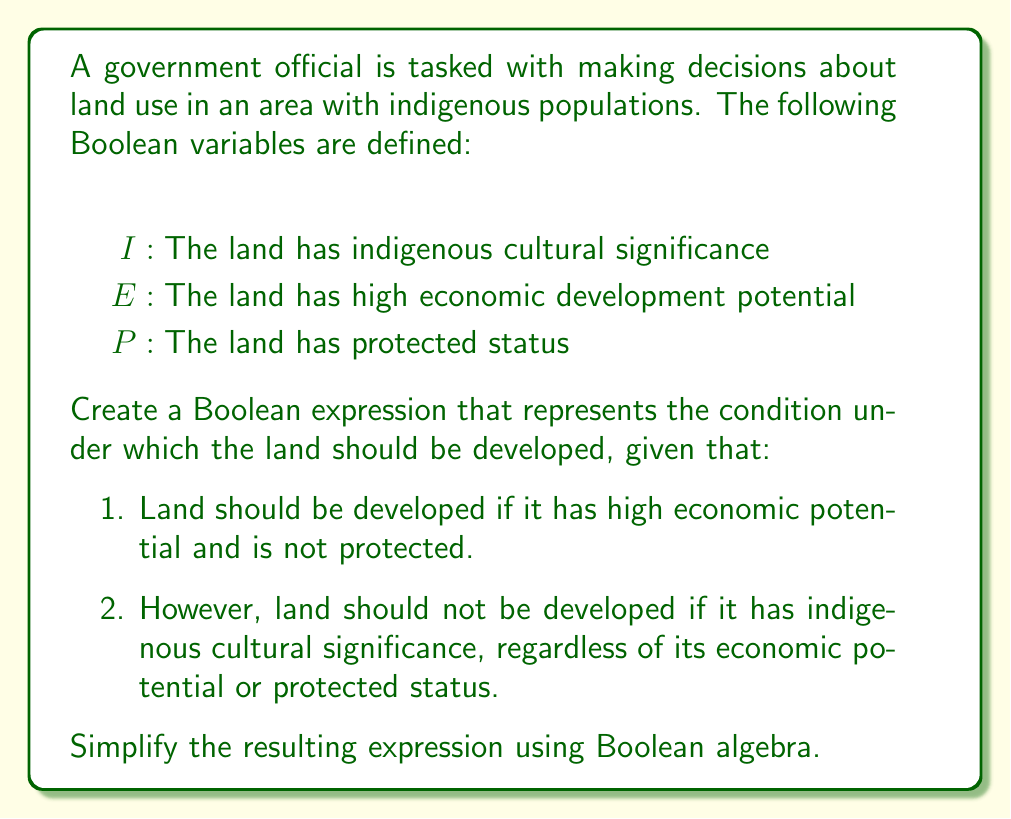What is the answer to this math problem? Let's approach this step-by-step:

1) First, let's express the conditions for development in Boolean terms:
   - Condition for development: $E \wedge \neg P$
   - Condition against development due to indigenous significance: $I$

2) The overall condition for development can be expressed as:
   $D = (E \wedge \neg P) \wedge \neg I$

3) Now, let's simplify this expression using Boolean algebra laws:
   $D = (E \wedge \neg P) \wedge \neg I$
   $= E \wedge \neg P \wedge \neg I$  (Associative law)

4) This expression is already in its simplest form, as it's a conjunction of three terms that cannot be further reduced.

5) Interpretation: Land should be developed (D) if and only if it has high economic potential (E) AND is not protected (¬P) AND does not have indigenous cultural significance (¬I).
Answer: $E \wedge \neg P \wedge \neg I$ 